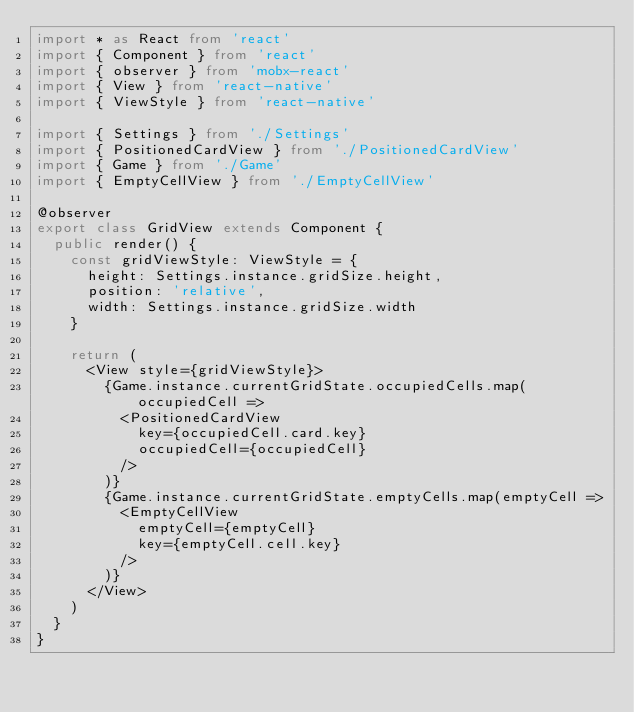<code> <loc_0><loc_0><loc_500><loc_500><_TypeScript_>import * as React from 'react'
import { Component } from 'react'
import { observer } from 'mobx-react'
import { View } from 'react-native'
import { ViewStyle } from 'react-native'

import { Settings } from './Settings'
import { PositionedCardView } from './PositionedCardView'
import { Game } from './Game'
import { EmptyCellView } from './EmptyCellView'

@observer
export class GridView extends Component {
  public render() {
    const gridViewStyle: ViewStyle = {
      height: Settings.instance.gridSize.height,
      position: 'relative',
      width: Settings.instance.gridSize.width
    }

    return (
      <View style={gridViewStyle}>
        {Game.instance.currentGridState.occupiedCells.map(occupiedCell =>
          <PositionedCardView
            key={occupiedCell.card.key}
            occupiedCell={occupiedCell}
          />
        )}
        {Game.instance.currentGridState.emptyCells.map(emptyCell =>
          <EmptyCellView
            emptyCell={emptyCell}
            key={emptyCell.cell.key}
          />
        )}
      </View>
    )
  }
}</code> 